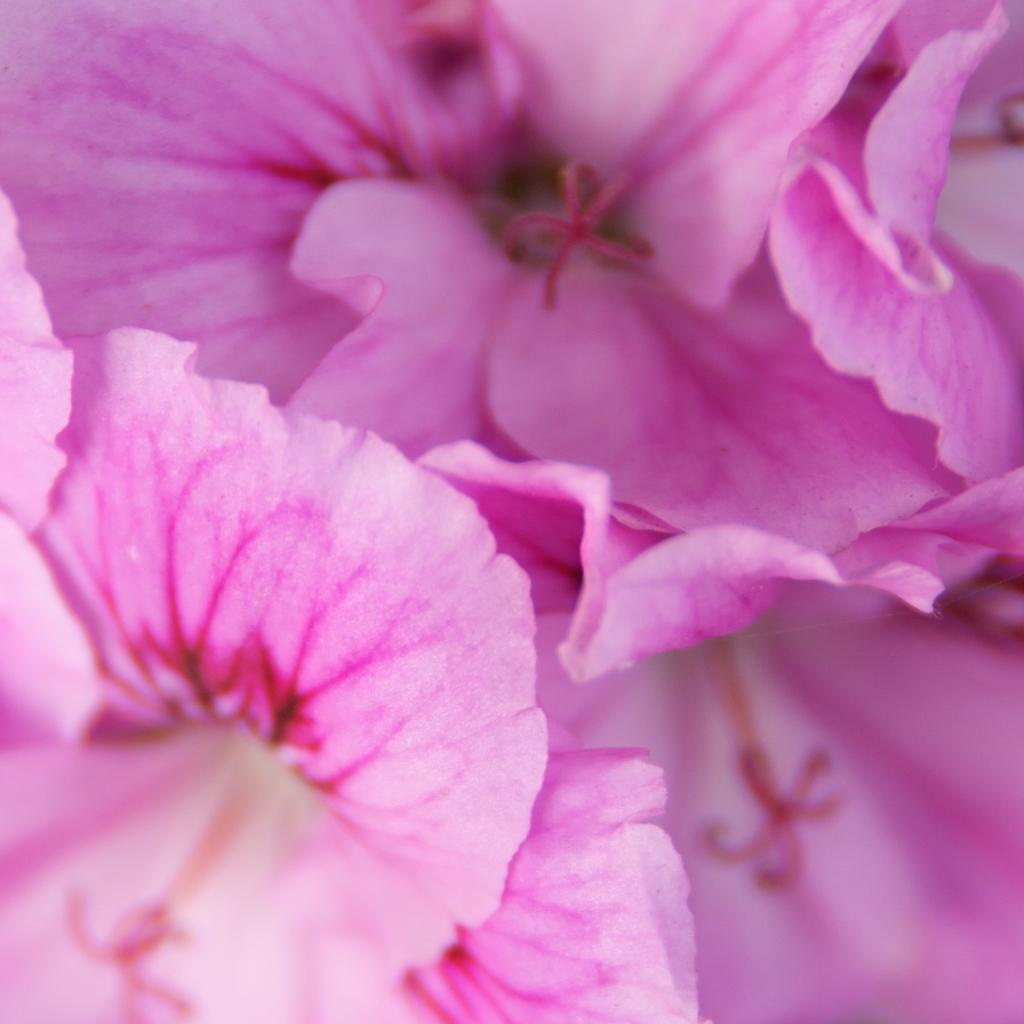What type of plants can be seen in the image? There are flowers in the image. What color are the flowers? The flowers are pink in color. What type of club can be seen in the image? There is no club present in the image; it features pink flowers. What type of home is visible in the image? There is no home present in the image; it features pink flowers. 